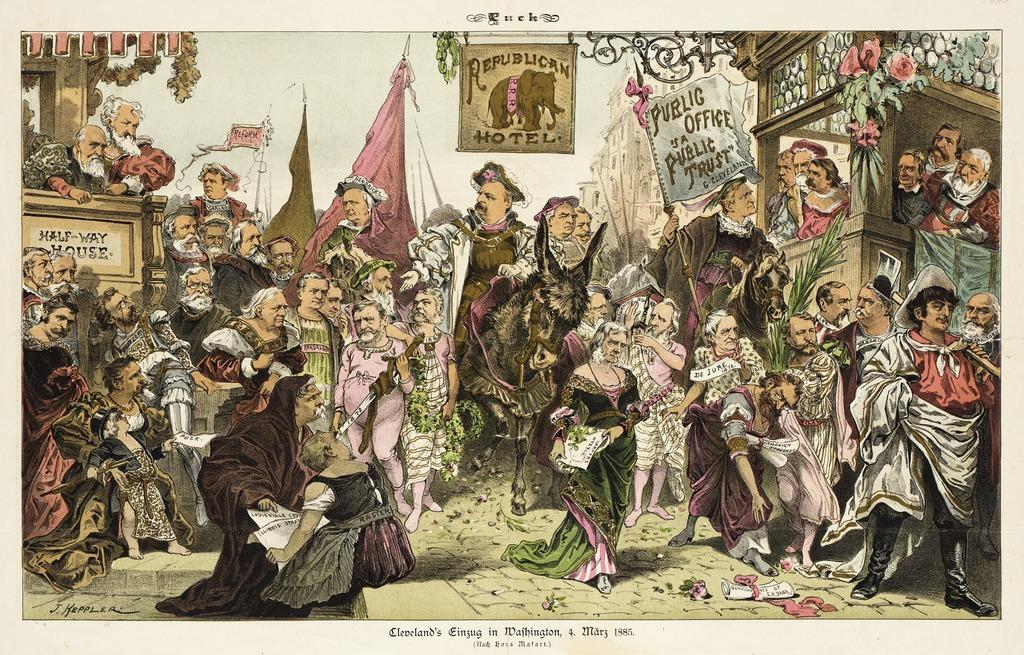What is happening on the road in the image? There is a group of people on the road in the image. What structures can be seen in the image? There are flagpoles, buildings, and posters in the image. What else is present in the image? There are animals in the image. What can be seen in the sky in the image? The sky is visible in the image. How is the image presented? The image appears to be a painting. What type of cheese is being used to create shade for the animals in the image? There is no cheese present in the image, and the animals are not being provided shade by any means. 